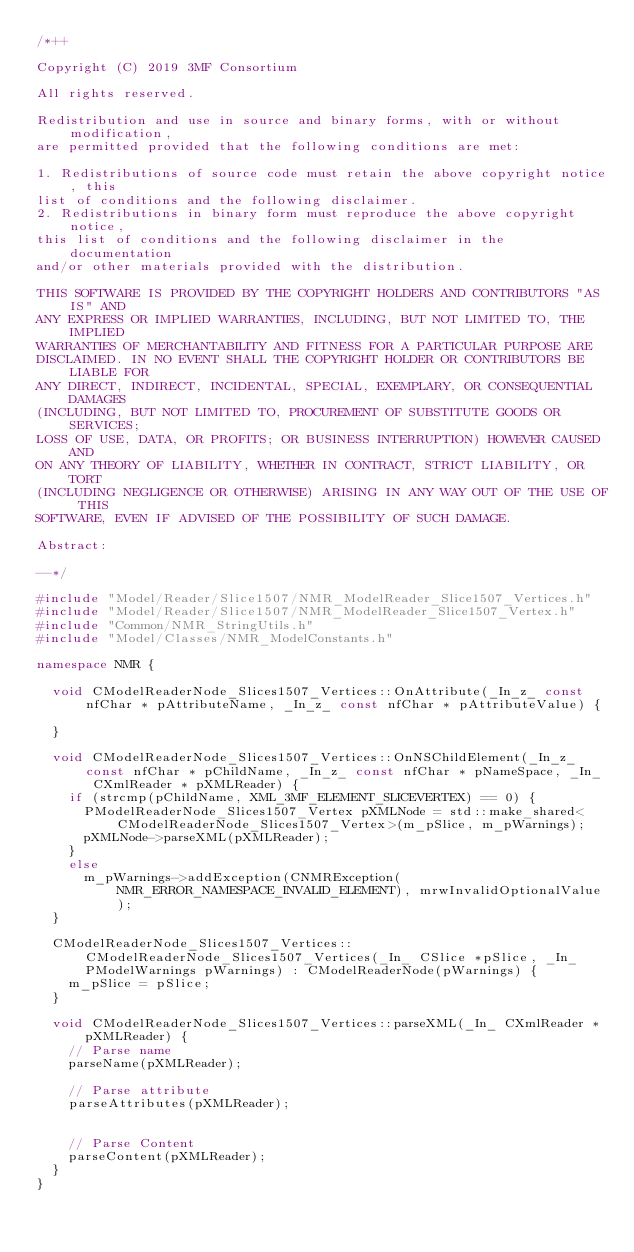Convert code to text. <code><loc_0><loc_0><loc_500><loc_500><_C++_>/*++

Copyright (C) 2019 3MF Consortium

All rights reserved.

Redistribution and use in source and binary forms, with or without modification,
are permitted provided that the following conditions are met:

1. Redistributions of source code must retain the above copyright notice, this
list of conditions and the following disclaimer.
2. Redistributions in binary form must reproduce the above copyright notice,
this list of conditions and the following disclaimer in the documentation
and/or other materials provided with the distribution.

THIS SOFTWARE IS PROVIDED BY THE COPYRIGHT HOLDERS AND CONTRIBUTORS "AS IS" AND
ANY EXPRESS OR IMPLIED WARRANTIES, INCLUDING, BUT NOT LIMITED TO, THE IMPLIED
WARRANTIES OF MERCHANTABILITY AND FITNESS FOR A PARTICULAR PURPOSE ARE
DISCLAIMED. IN NO EVENT SHALL THE COPYRIGHT HOLDER OR CONTRIBUTORS BE LIABLE FOR
ANY DIRECT, INDIRECT, INCIDENTAL, SPECIAL, EXEMPLARY, OR CONSEQUENTIAL DAMAGES
(INCLUDING, BUT NOT LIMITED TO, PROCUREMENT OF SUBSTITUTE GOODS OR SERVICES;
LOSS OF USE, DATA, OR PROFITS; OR BUSINESS INTERRUPTION) HOWEVER CAUSED AND
ON ANY THEORY OF LIABILITY, WHETHER IN CONTRACT, STRICT LIABILITY, OR TORT
(INCLUDING NEGLIGENCE OR OTHERWISE) ARISING IN ANY WAY OUT OF THE USE OF THIS
SOFTWARE, EVEN IF ADVISED OF THE POSSIBILITY OF SUCH DAMAGE.

Abstract:

--*/

#include "Model/Reader/Slice1507/NMR_ModelReader_Slice1507_Vertices.h"
#include "Model/Reader/Slice1507/NMR_ModelReader_Slice1507_Vertex.h"
#include "Common/NMR_StringUtils.h"
#include "Model/Classes/NMR_ModelConstants.h"

namespace NMR {

	void CModelReaderNode_Slices1507_Vertices::OnAttribute(_In_z_ const nfChar * pAttributeName, _In_z_ const nfChar * pAttributeValue) {

	}

	void CModelReaderNode_Slices1507_Vertices::OnNSChildElement(_In_z_ const nfChar * pChildName, _In_z_ const nfChar * pNameSpace, _In_ CXmlReader * pXMLReader) {
		if (strcmp(pChildName, XML_3MF_ELEMENT_SLICEVERTEX) == 0) {
			PModelReaderNode_Slices1507_Vertex pXMLNode = std::make_shared<CModelReaderNode_Slices1507_Vertex>(m_pSlice, m_pWarnings);
			pXMLNode->parseXML(pXMLReader);
		}
		else
			m_pWarnings->addException(CNMRException(NMR_ERROR_NAMESPACE_INVALID_ELEMENT), mrwInvalidOptionalValue);
	}

	CModelReaderNode_Slices1507_Vertices::CModelReaderNode_Slices1507_Vertices(_In_ CSlice *pSlice, _In_ PModelWarnings pWarnings) : CModelReaderNode(pWarnings) {
		m_pSlice = pSlice;
	}

	void CModelReaderNode_Slices1507_Vertices::parseXML(_In_ CXmlReader * pXMLReader) {
		// Parse name
		parseName(pXMLReader);

		// Parse attribute
		parseAttributes(pXMLReader);


		// Parse Content
		parseContent(pXMLReader);
	}
}
</code> 